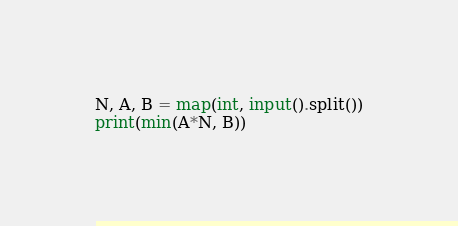<code> <loc_0><loc_0><loc_500><loc_500><_Python_>N, A, B = map(int, input().split())
print(min(A*N, B))</code> 